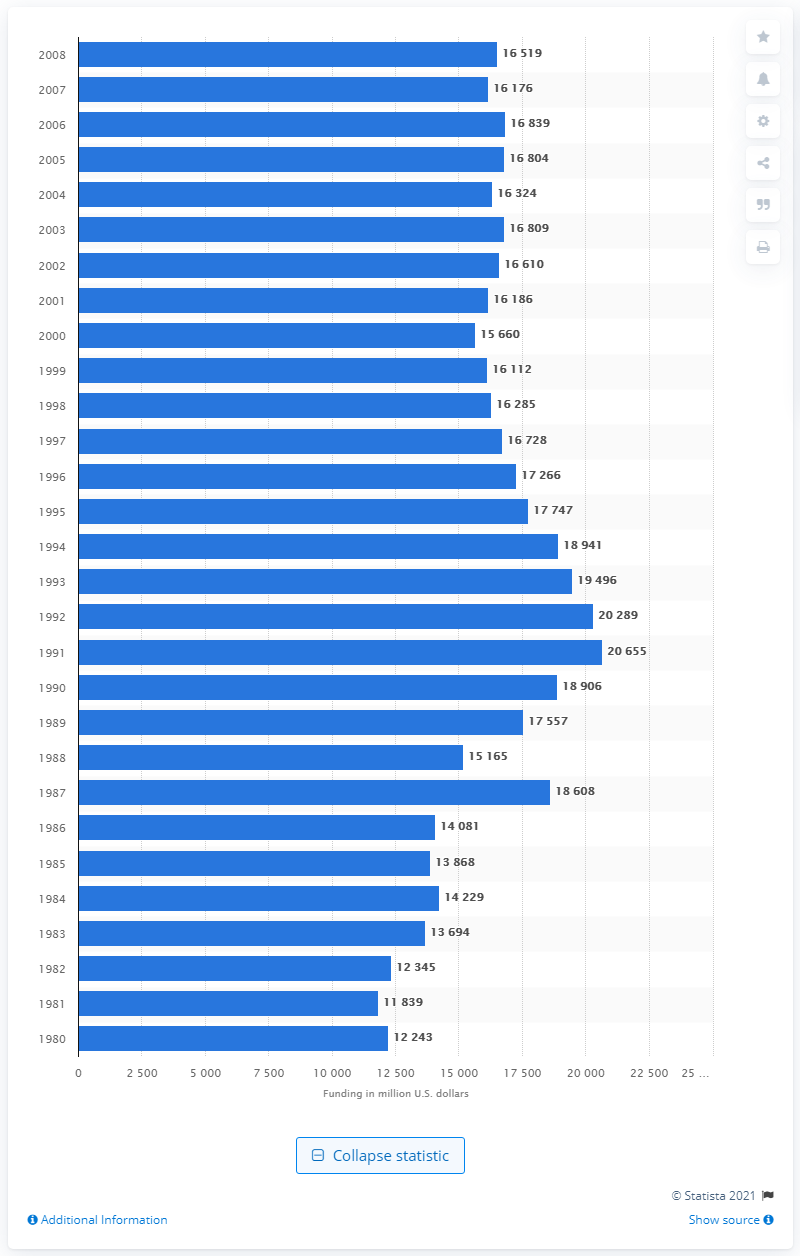Highlight a few significant elements in this photo. In 2008, NASA received an amount of money that can be represented as 16,519. 